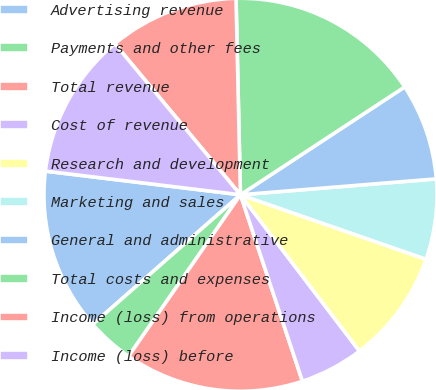<chart> <loc_0><loc_0><loc_500><loc_500><pie_chart><fcel>Advertising revenue<fcel>Payments and other fees<fcel>Total revenue<fcel>Cost of revenue<fcel>Research and development<fcel>Marketing and sales<fcel>General and administrative<fcel>Total costs and expenses<fcel>Income (loss) from operations<fcel>Income (loss) before<nl><fcel>13.39%<fcel>3.89%<fcel>14.75%<fcel>5.25%<fcel>9.32%<fcel>6.61%<fcel>7.96%<fcel>16.11%<fcel>10.68%<fcel>12.04%<nl></chart> 